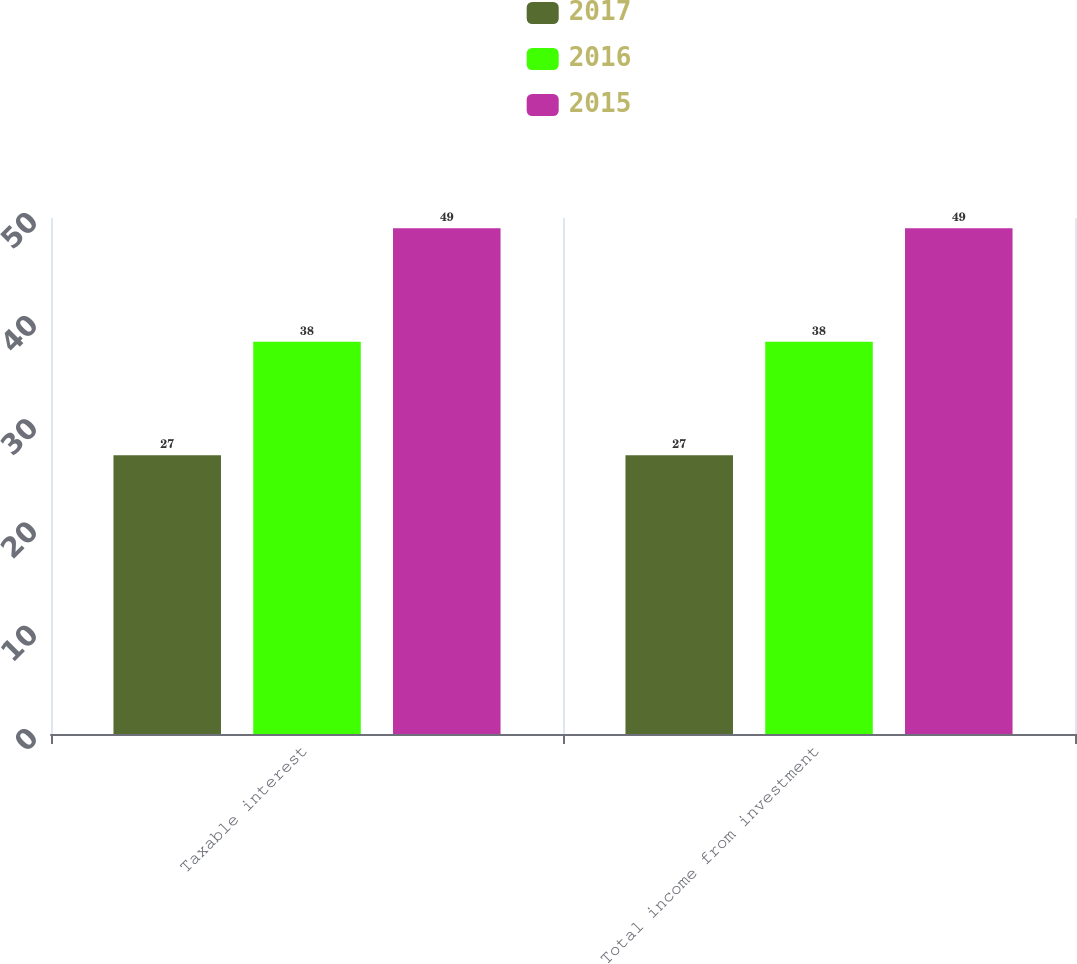Convert chart. <chart><loc_0><loc_0><loc_500><loc_500><stacked_bar_chart><ecel><fcel>Taxable interest<fcel>Total income from investment<nl><fcel>2017<fcel>27<fcel>27<nl><fcel>2016<fcel>38<fcel>38<nl><fcel>2015<fcel>49<fcel>49<nl></chart> 